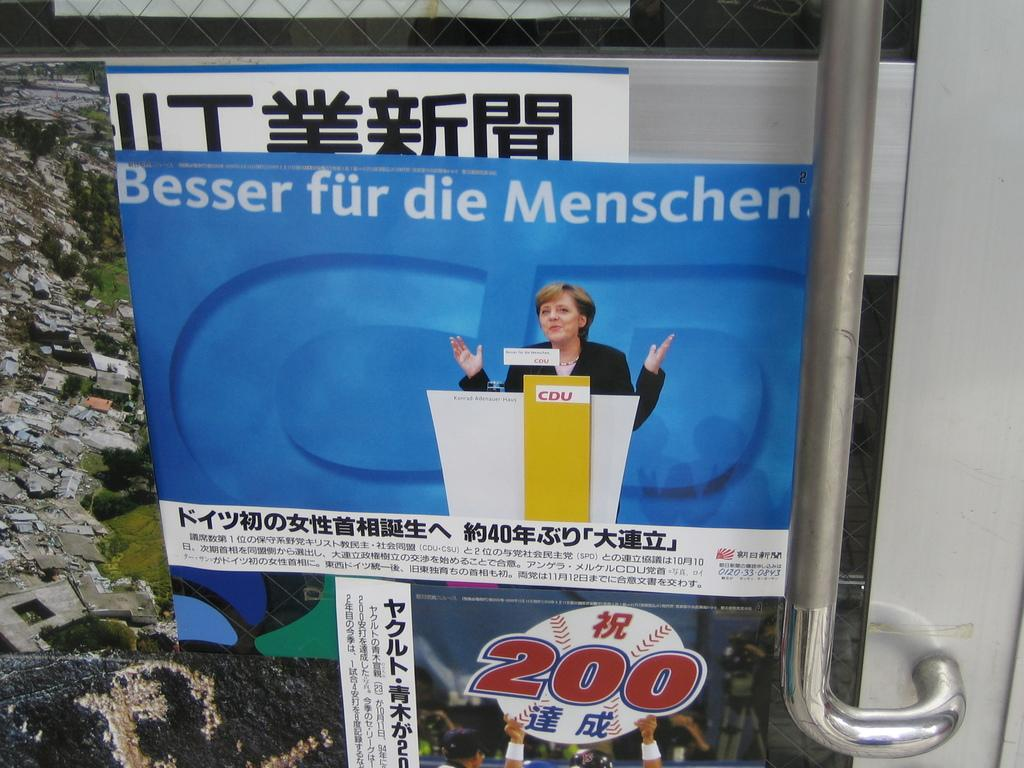<image>
Summarize the visual content of the image. A poster of a lady in a podium with the number 200 on top of a baseball ball. 